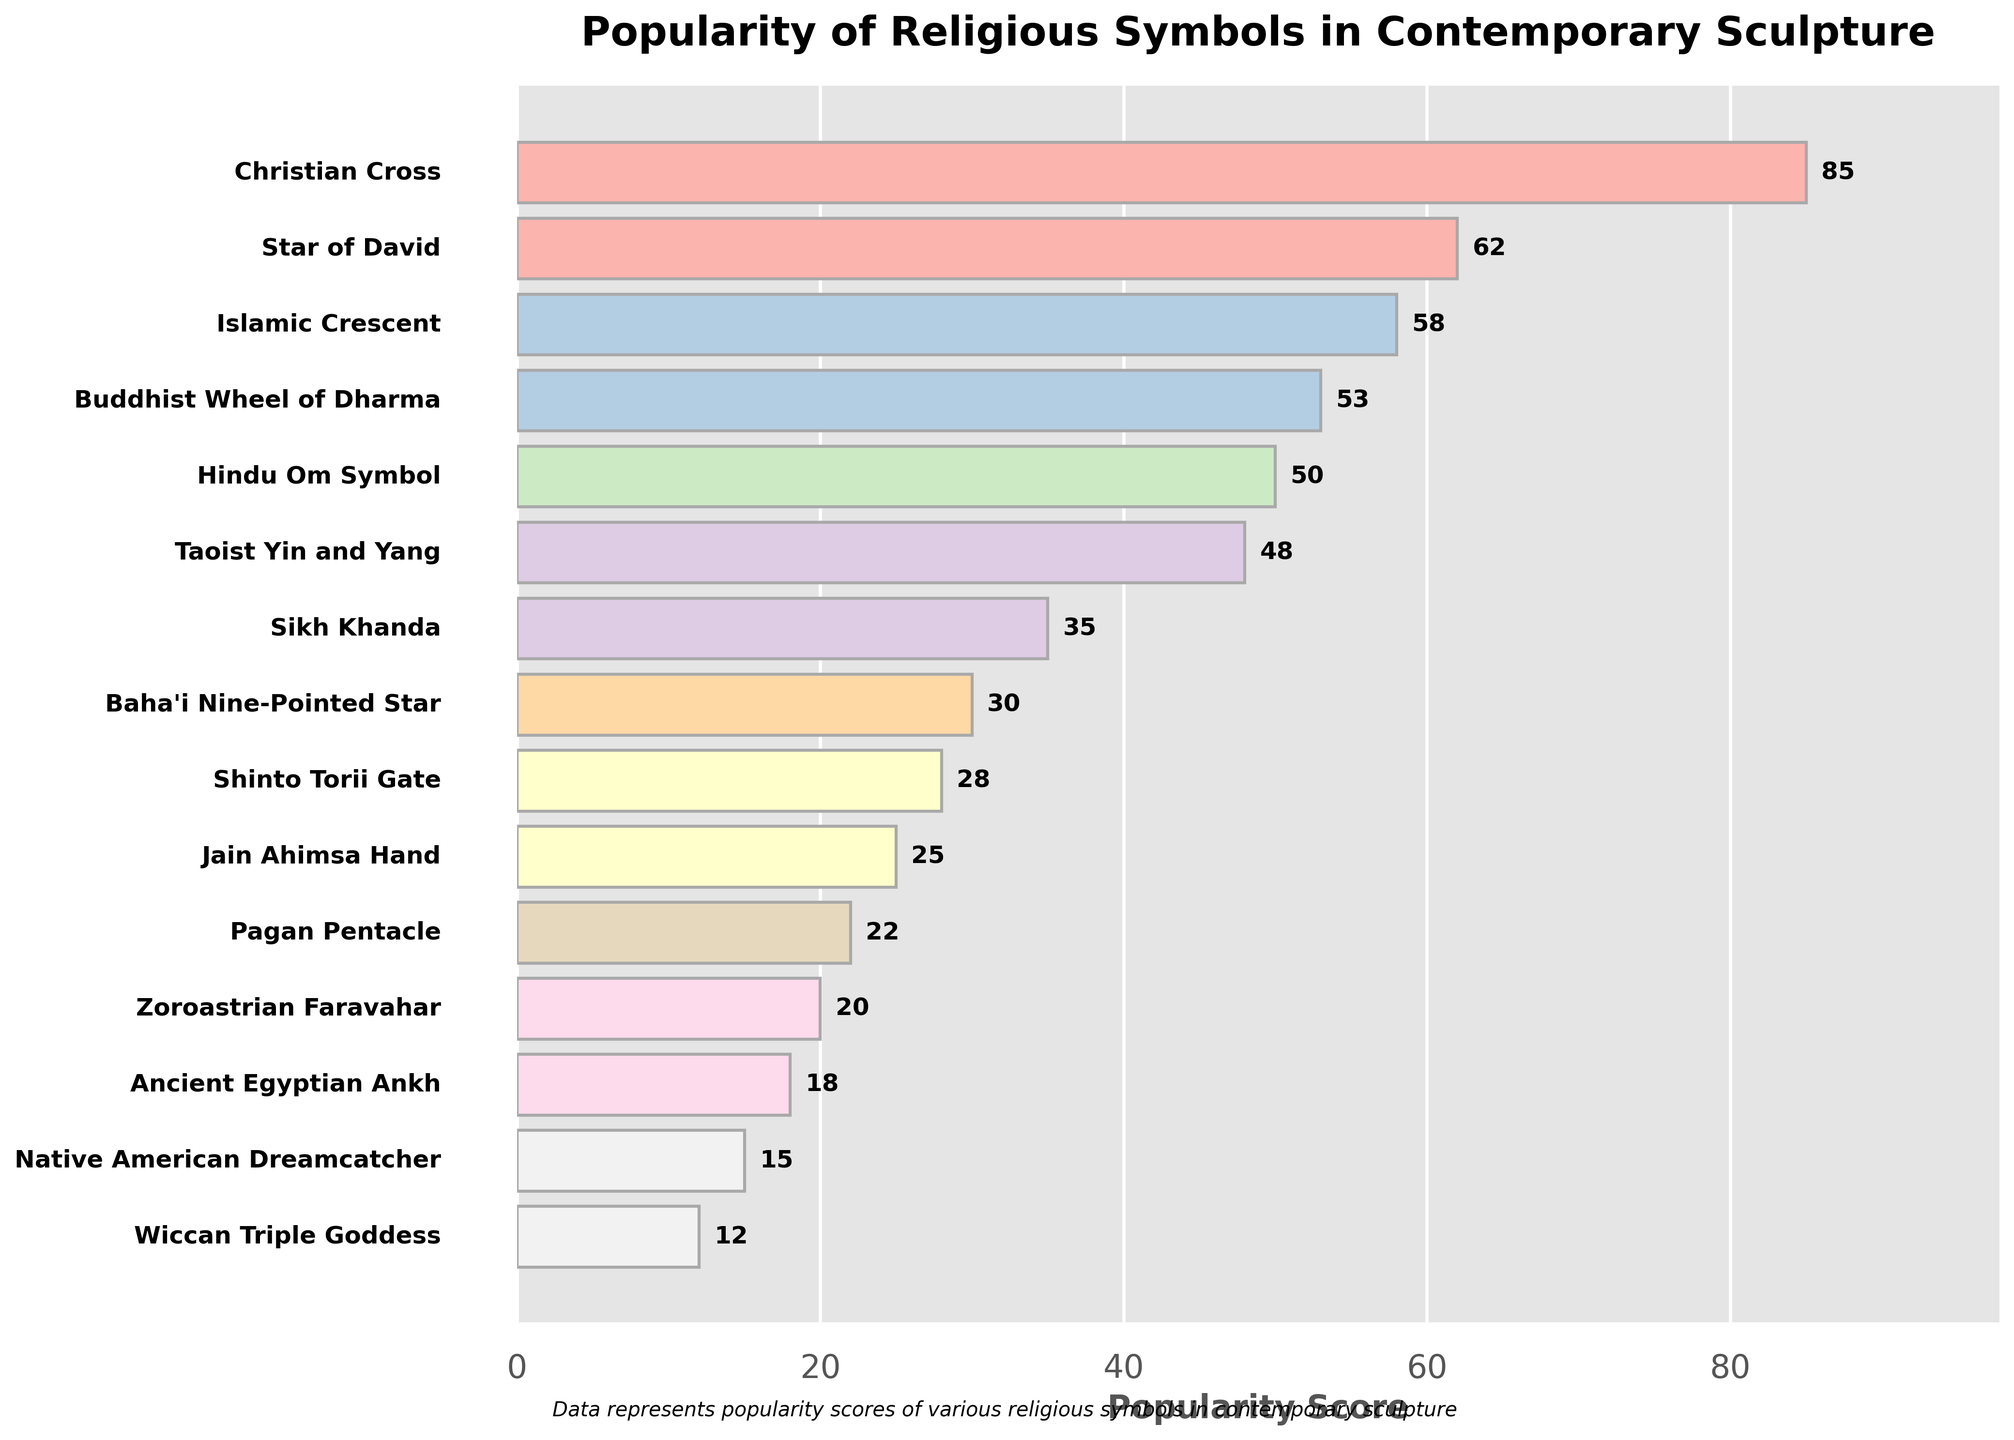Which religious symbol has the highest popularity score in contemporary sculpture? By examining the bar chart, we can see that the Christian Cross has the longest bar, indicating the highest popularity score.
Answer: Christian Cross What is the total popularity score for the Buddhist Wheel of Dharma and the Islamic Crescent? The Buddhist Wheel of Dharma has a score of 53, and the Islamic Crescent has a score of 58. Adding these together: 53 + 58 = 111.
Answer: 111 How many religious symbols have a popularity score above 50? Looking at the chart, the symbols with scores above 50 are Christian Cross, Star of David, Islamic Crescent, Buddhist Wheel of Dharma, and Hindu Om Symbol, totaling 5 symbols.
Answer: 5 Which religious symbol has the lowest popularity score? The Wiccan Triple Goddess has the smallest bar in the chart, indicating the lowest popularity score of 12.
Answer: Wiccan Triple Goddess By how much does the popularity score of the Star of David exceed that of the Native American Dreamcatcher? The Star of David has a score of 62, and the Native American Dreamcatcher has a score of 15. Subtracting these: 62 - 15 = 47.
Answer: 47 What is the average popularity score of the top three most popular religious symbols? The scores of the top three symbols are Christian Cross (85), Star of David (62), and Islamic Crescent (58). Adding these and dividing by 3: (85 + 62 + 58) / 3 = 205 / 3 ≈ 68.33.
Answer: 68.33 How many symbols have a popularity score between 20 and 50? The bars representing the Hindu Om Symbol, Taoist Yin and Yang, Sikh Khanda, Baha’i Nine-Pointed Star, Shinto Torii Gate, Jain Ahimsa Hand, and Pagan Pentacle fall within this range, totaling 7 symbols.
Answer: 7 Which two symbols have the closest popularity scores, and what is the difference? The differences between adjacent symbols' scores indicate that the Taoist Yin and Yang (48) and the Hindu Om Symbol (50) are the closest, with a difference of 50 - 48 = 2.
Answer: Hindu Om Symbol and Taoist Yin and Yang, 2 How much more popular is the Hindu Om Symbol compared to the Pagan Pentacle? The Hindu Om Symbol has a popularity score of 50, and the Pagan Pentacle has a score of 22. The difference is 50 - 22 = 28.
Answer: 28 